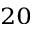<formula> <loc_0><loc_0><loc_500><loc_500>_ { 2 0 }</formula> 